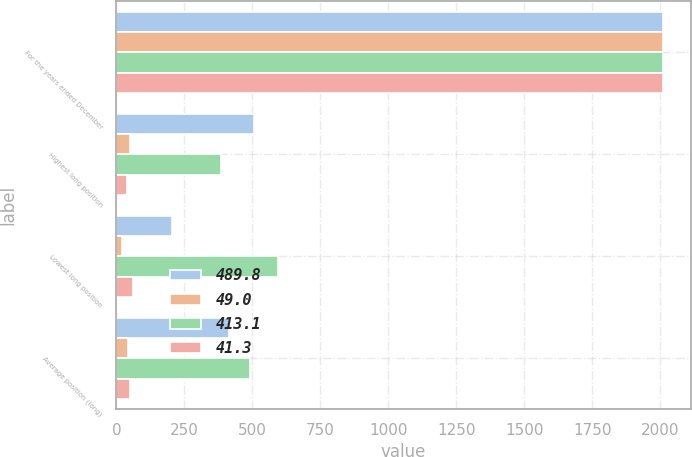Convert chart. <chart><loc_0><loc_0><loc_500><loc_500><stacked_bar_chart><ecel><fcel>For the years ended December<fcel>Highest long position<fcel>Lowest long position<fcel>Average position (long)<nl><fcel>489.8<fcel>2011<fcel>505.9<fcel>204.8<fcel>413.1<nl><fcel>49<fcel>2011<fcel>50.6<fcel>20.5<fcel>41.3<nl><fcel>413.1<fcel>2010<fcel>386.2<fcel>594.6<fcel>489.8<nl><fcel>41.3<fcel>2010<fcel>38.6<fcel>59.5<fcel>49<nl></chart> 